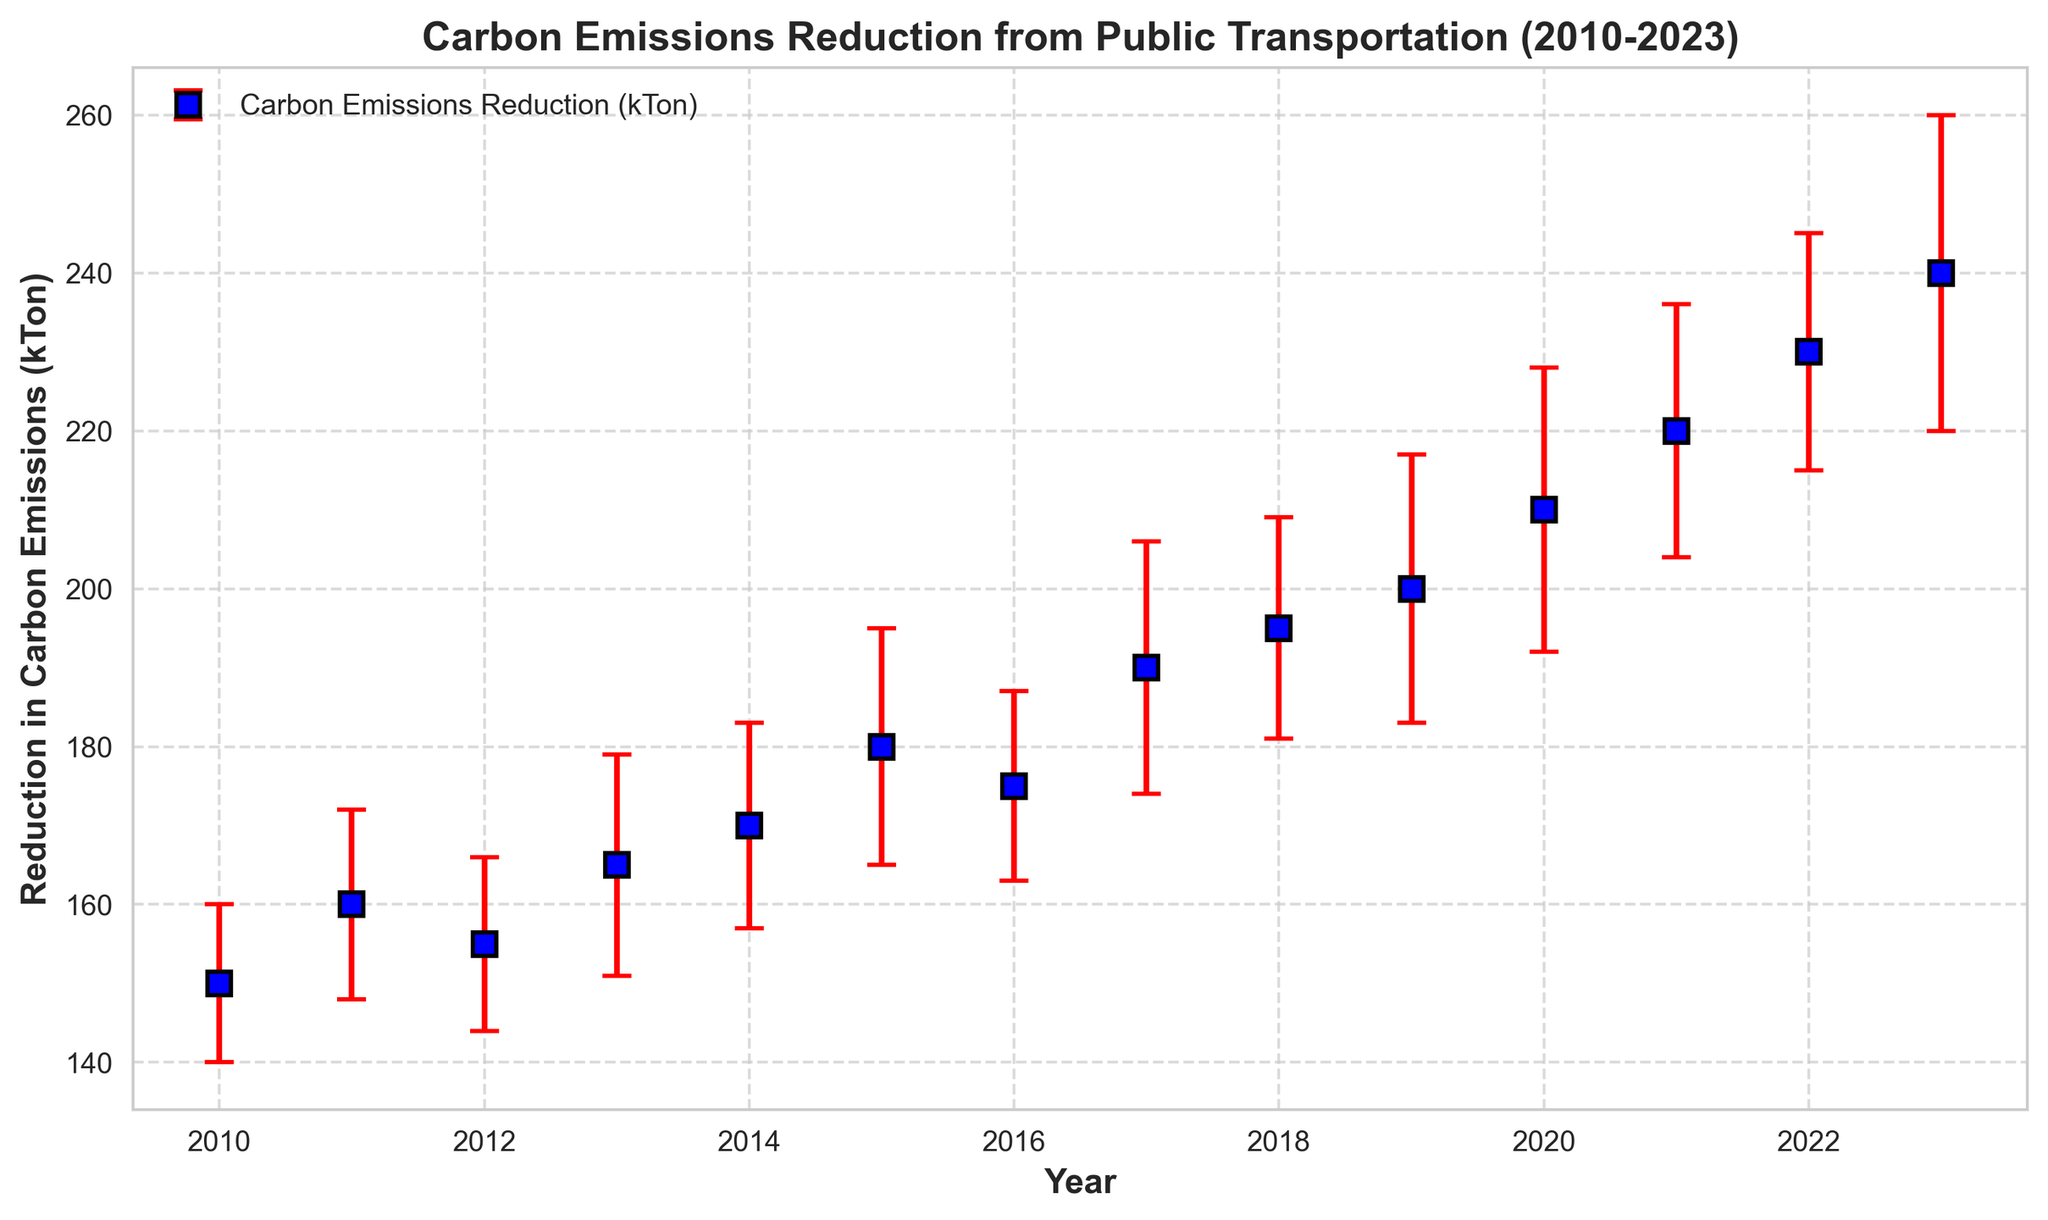What's the average carbon emissions reduction between 2010 and 2015? Calculate the sum of the reductions from 2010 to 2015 (150 + 160 + 155 + 165 + 170 + 180) = 980. There are 6 years, so the average is 980 / 6 = 163.33 kTon
Answer: 163.33 kTon Which year shows the highest reduction in carbon emissions? By looking at the data points, the highest reduction is in 2023 with 240 kTon.
Answer: 2023 What is the difference in carbon emissions reduction between the year with the highest and the year with the lowest recorded reductions? The highest reduction is in 2023 with 240 kTon, and the lowest is in 2010 with 150 kTon. The difference is 240 - 150 = 90 kTon.
Answer: 90 kTon Is the error bar for 2020 larger than for 2012? The error bar for 2020 is 18 kTon, while for 2012 it is 11 kTon. Thus, the error bar for 2020 is larger.
Answer: Yes By how much did the carbon emissions reduction increase from 2011 to 2012? The reduction in 2011 is 160 kTon, and in 2012 it's 155 kTon. The difference is 155 - 160 = -5 kTon (a decrease).
Answer: -5 kTon Does the chart show a continuous trend of increasing carbon emissions reduction over the years? No, the chart shows fluctuations in certain years, especially 2012, 2016, and a consistent increase starting from 2019 onwards.
Answer: No Which years have an error bar of 15 kTon? The years with an error bar of 15 kTon are 2015 and 2022.
Answer: 2015 and 2022 What is the total carbon emissions reduction from 2020 to 2023? Calculate the sum of the reductions from 2020 to 2023 (210 + 220 + 230 + 240) = 900 kTon.
Answer: 900 kTon How does the carbon emissions reduction in 2017 compare with 2015 in terms of both value and error bar? In 2017, the reduction is 190 kTon with a 16 kTon error bar, while in 2015, it is 180 kTon with a 15 kTon error bar. The 2017 reduction is 10 kTon higher with a 1 kTon larger error bar.
Answer: 10 kTon higher, 1 kTon larger error bar In which year did the carbon emissions reduction first exceed 200 kTon? The carbon emissions reduction first exceeded 200 kTon in 2020.
Answer: 2020 